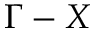<formula> <loc_0><loc_0><loc_500><loc_500>\Gamma - X</formula> 